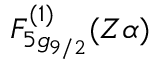<formula> <loc_0><loc_0><loc_500><loc_500>F _ { 5 g _ { 9 / 2 } } ^ { ( 1 ) } ( Z \alpha )</formula> 